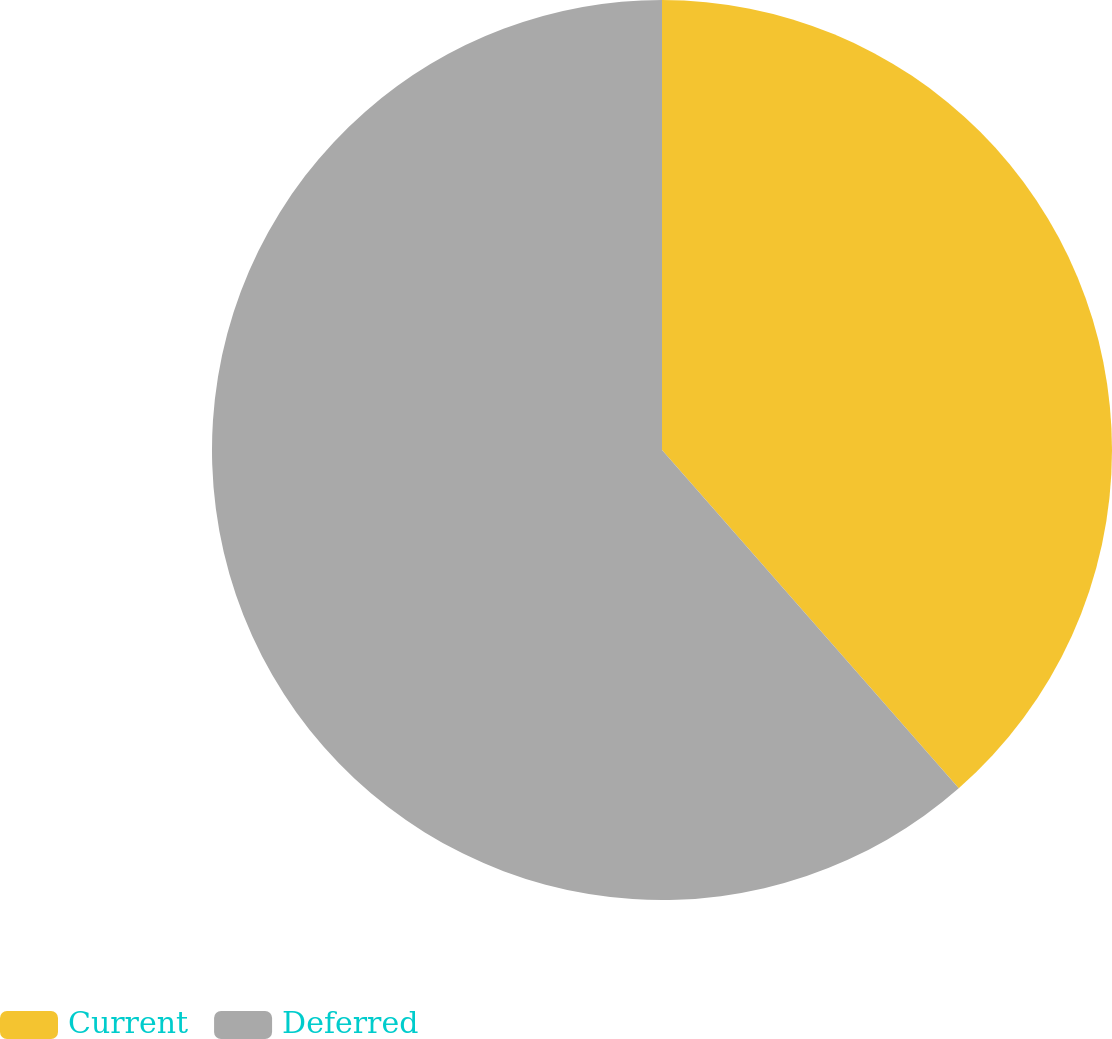Convert chart. <chart><loc_0><loc_0><loc_500><loc_500><pie_chart><fcel>Current<fcel>Deferred<nl><fcel>38.54%<fcel>61.46%<nl></chart> 